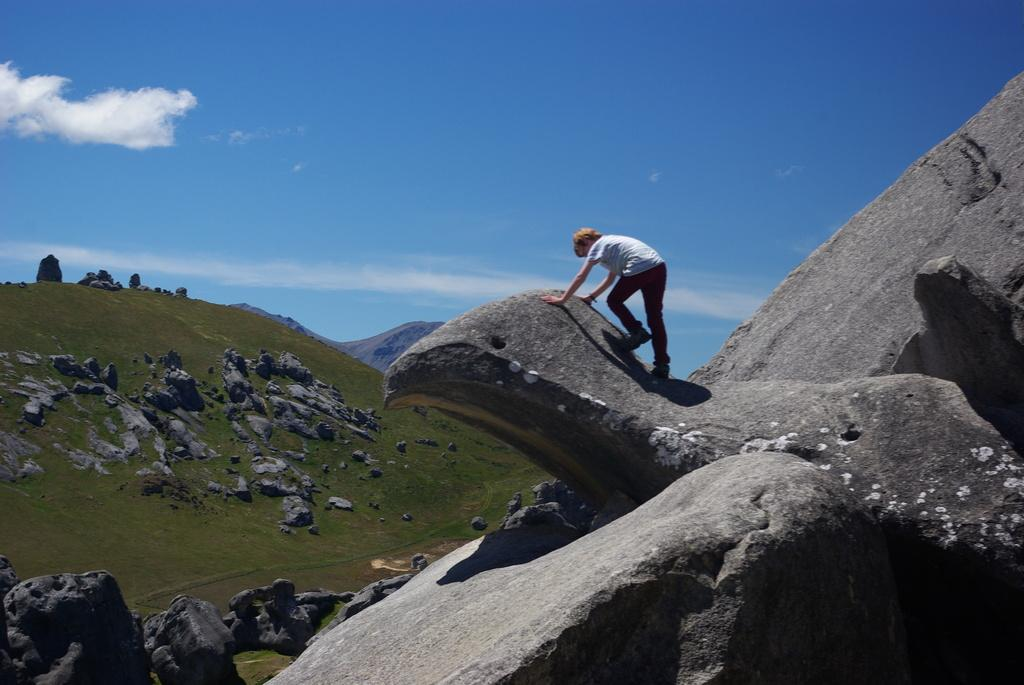What type of natural formation can be seen in the image? There are mountains in the image. What is the person in the image doing? The person is climbing in the image. What part of the environment is visible in the image? The sky is visible in the image. What colors can be seen in the sky in the image? The sky has white and blue colors in the image. Where are the trains located in the image? There are no trains present in the image. What type of learning activity is the person engaged in while climbing? The image does not provide information about any learning activity; it simply shows a person climbing. 